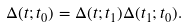<formula> <loc_0><loc_0><loc_500><loc_500>\Delta ( t ; t _ { 0 } ) = \Delta ( t ; t _ { 1 } ) \Delta ( t _ { 1 } ; t _ { 0 } ) .</formula> 